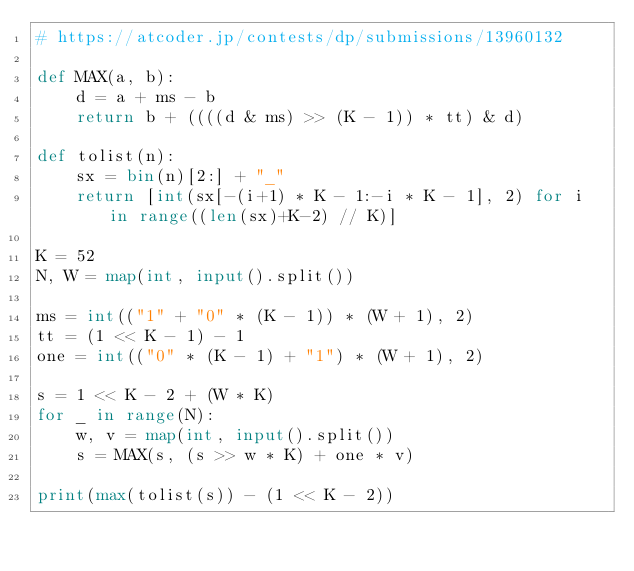<code> <loc_0><loc_0><loc_500><loc_500><_Python_># https://atcoder.jp/contests/dp/submissions/13960132

def MAX(a, b):
    d = a + ms - b
    return b + ((((d & ms) >> (K - 1)) * tt) & d)

def tolist(n):
    sx = bin(n)[2:] + "_"
    return [int(sx[-(i+1) * K - 1:-i * K - 1], 2) for i in range((len(sx)+K-2) // K)]

K = 52
N, W = map(int, input().split())

ms = int(("1" + "0" * (K - 1)) * (W + 1), 2)
tt = (1 << K - 1) - 1
one = int(("0" * (K - 1) + "1") * (W + 1), 2)

s = 1 << K - 2 + (W * K)
for _ in range(N):
    w, v = map(int, input().split())
    s = MAX(s, (s >> w * K) + one * v)

print(max(tolist(s)) - (1 << K - 2))</code> 